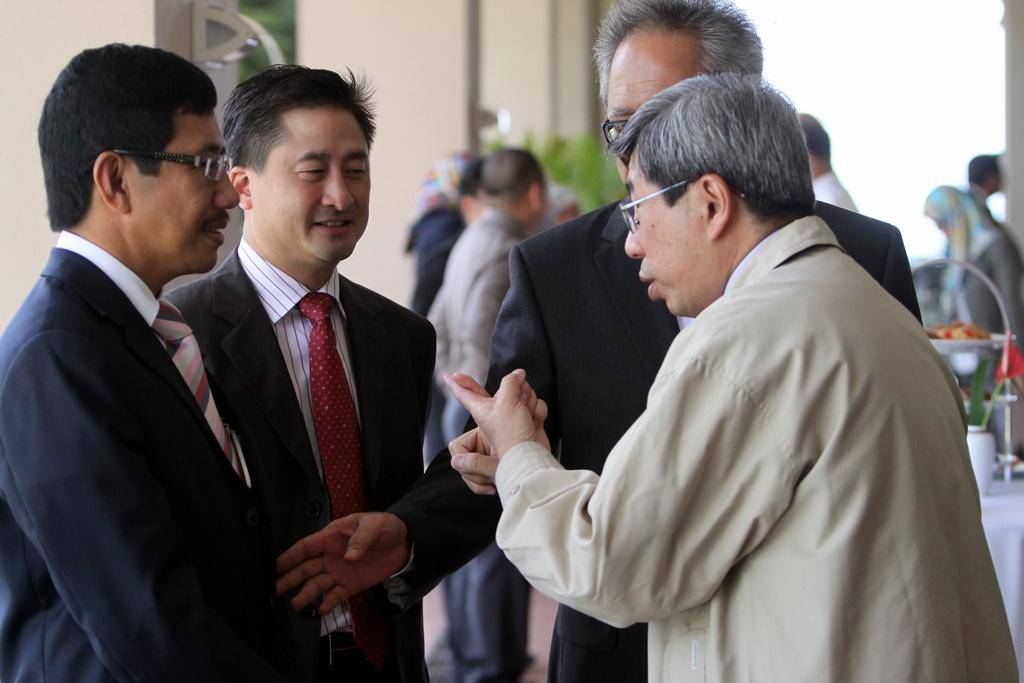How many groups of people can be seen in the image? There are two groups of people in the image. What are the people in the first group wearing? Some of the people in the first group are wearing suits. Can you describe the people in the second group? There are other people behind the first group, but their clothing is not specified in the facts. What type of plant is present in the image? The facts do not specify the type of plant in the image. What type of glove is being used by the person playing the instrument in the image? There is no person playing an instrument in the image, and therefore no glove can be associated with it. 